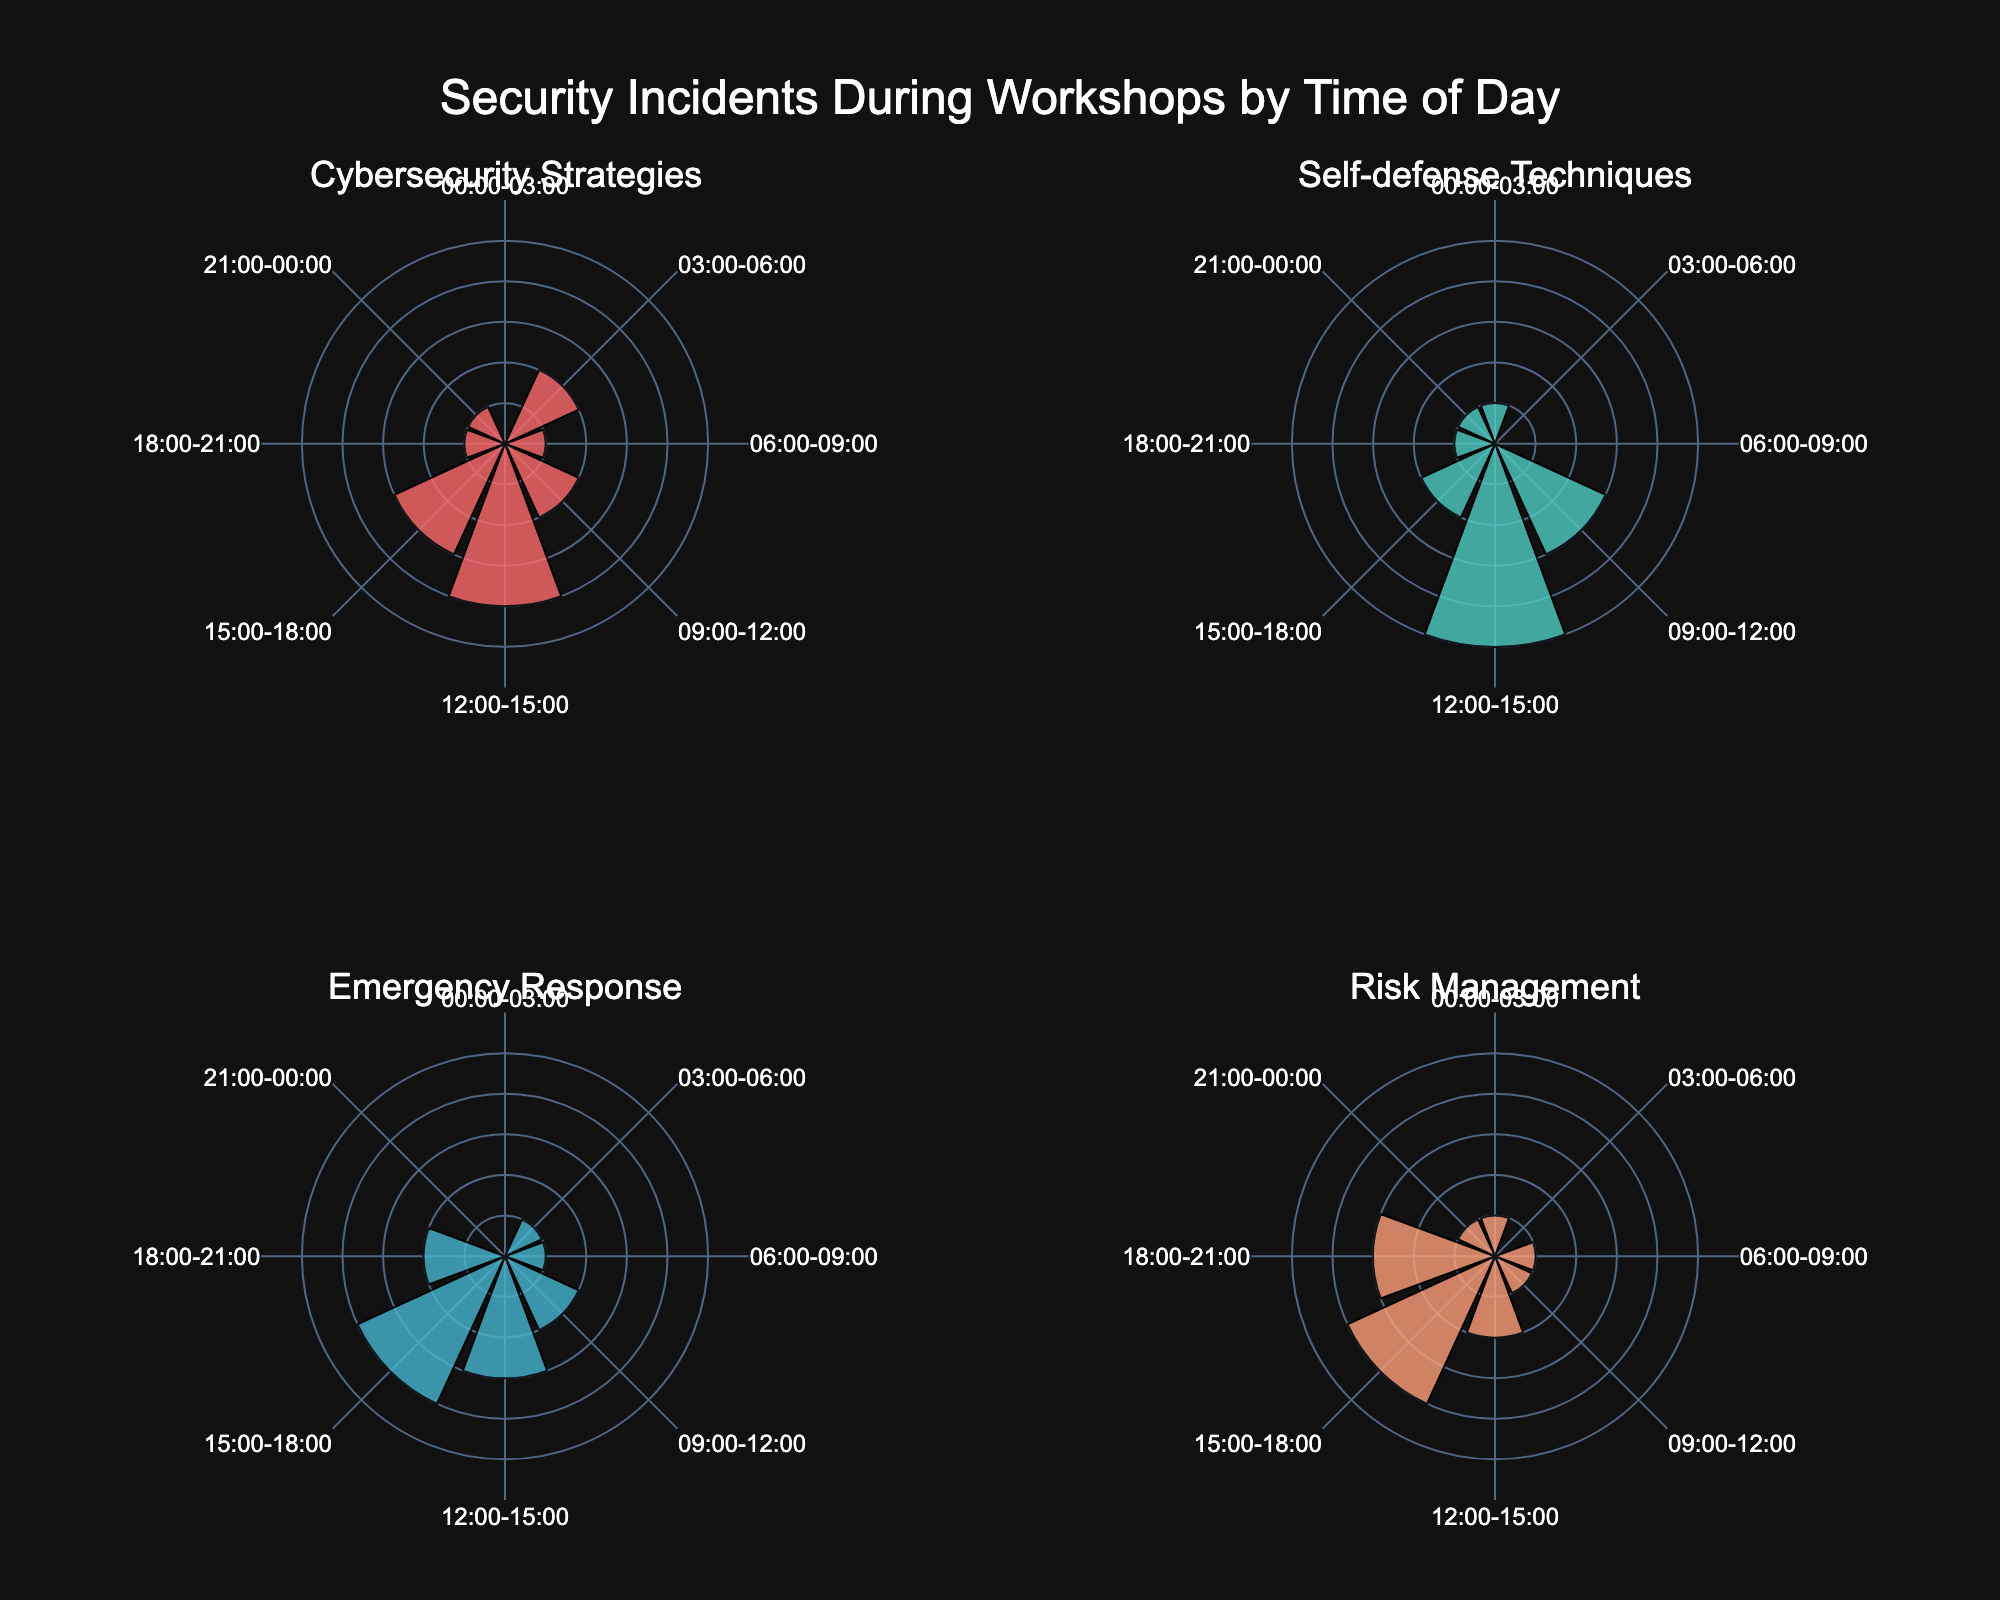What is the title of the figure? The title of the figure is located at the top center and provides a summary of what the visual information represents.
Answer: Security Incidents During Workshops by Time of Day Which workshop has the highest number of security incidents during the 12:00-15:00 time slot? Identify the segment corresponding to the 12:00-15:00 time slot for each workshop and compare the heights.
Answer: Self-defense Techniques How many workshops report security incidents during the 00:00-03:00 time slot? Count the number of segments with non-zero values in the 00:00-03:00 time slot across all subplots.
Answer: Three What is the total number of security incidents reported for the Cybersecurity Strategies workshop? Sum the heights of all segments in the Cybersecurity Strategies subplot.
Answer: 14 Which workshop has the most uniform distribution of security incidents across different time slots? Look for the subplot where the segment heights are relatively equal across all time slots.
Answer: Risk Management How does the number of security incidents from 15:00-18:00 compare between Cybersecurity Strategies and Self-defense Techniques workshops? Compare the height of the segments corresponding to the 15:00-18:00 time slot between these two subplots.
Answer: Cybersecurity Strategies has 1 more incident During which time slot does Risk Management report its maximum security incidents? Look for the highest segment in the Risk Management subplot and note the corresponding time period.
Answer: 15:00-18:00 Compare the number of incidents for the 09:00-12:00 time slot between Emergency Response and Self-defense Techniques. Which workshop has more? Compare the height of the segments for the 09:00-12:00 time slot between these two subplots.
Answer: Self-defense Techniques What is the average number of security incidents reported across all workshops during the 18:00-21:00 time slot? Find the total number of incidents for the 18:00-21:00 time slot for every workshop and divide by the number of workshops.
Answer: 1.75 